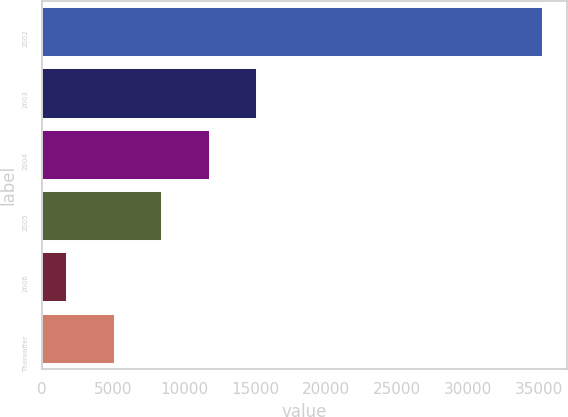<chart> <loc_0><loc_0><loc_500><loc_500><bar_chart><fcel>2002<fcel>2003<fcel>2004<fcel>2005<fcel>2006<fcel>Thereafter<nl><fcel>35197<fcel>15083.8<fcel>11731.6<fcel>8379.4<fcel>1675<fcel>5027.2<nl></chart> 